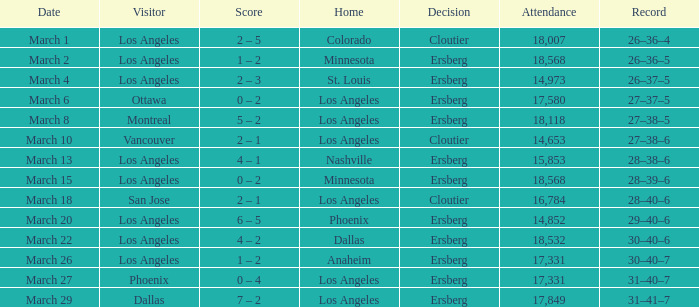On the Date of March 13, who was the Home team? Nashville. 